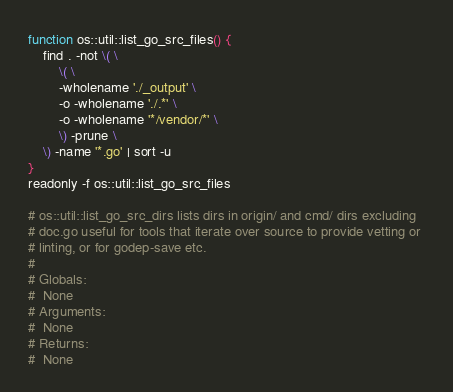<code> <loc_0><loc_0><loc_500><loc_500><_Bash_>function os::util::list_go_src_files() {
	find . -not \( \
		\( \
		-wholename './_output' \
		-o -wholename './.*' \
		-o -wholename '*/vendor/*' \
		\) -prune \
	\) -name '*.go' | sort -u
}
readonly -f os::util::list_go_src_files

# os::util::list_go_src_dirs lists dirs in origin/ and cmd/ dirs excluding
# doc.go useful for tools that iterate over source to provide vetting or 
# linting, or for godep-save etc.
#
# Globals:
#  None
# Arguments:
#  None
# Returns:
#  None</code> 